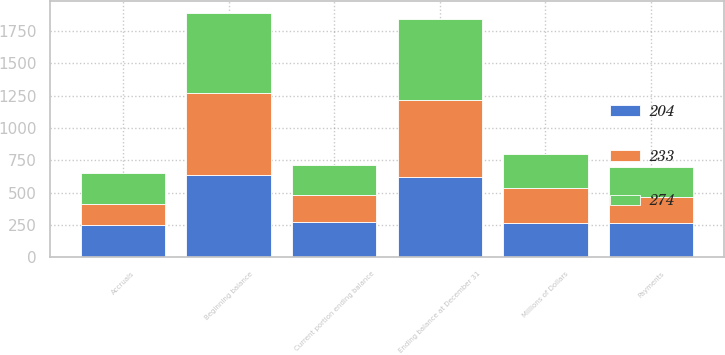Convert chart. <chart><loc_0><loc_0><loc_500><loc_500><stacked_bar_chart><ecel><fcel>Millions of Dollars<fcel>Beginning balance<fcel>Accruals<fcel>Payments<fcel>Ending balance at December 31<fcel>Current portion ending balance<nl><fcel>233<fcel>267<fcel>631<fcel>165<fcel>203<fcel>593<fcel>204<nl><fcel>274<fcel>267<fcel>619<fcel>240<fcel>228<fcel>631<fcel>233<nl><fcel>204<fcel>267<fcel>639<fcel>247<fcel>267<fcel>619<fcel>274<nl></chart> 